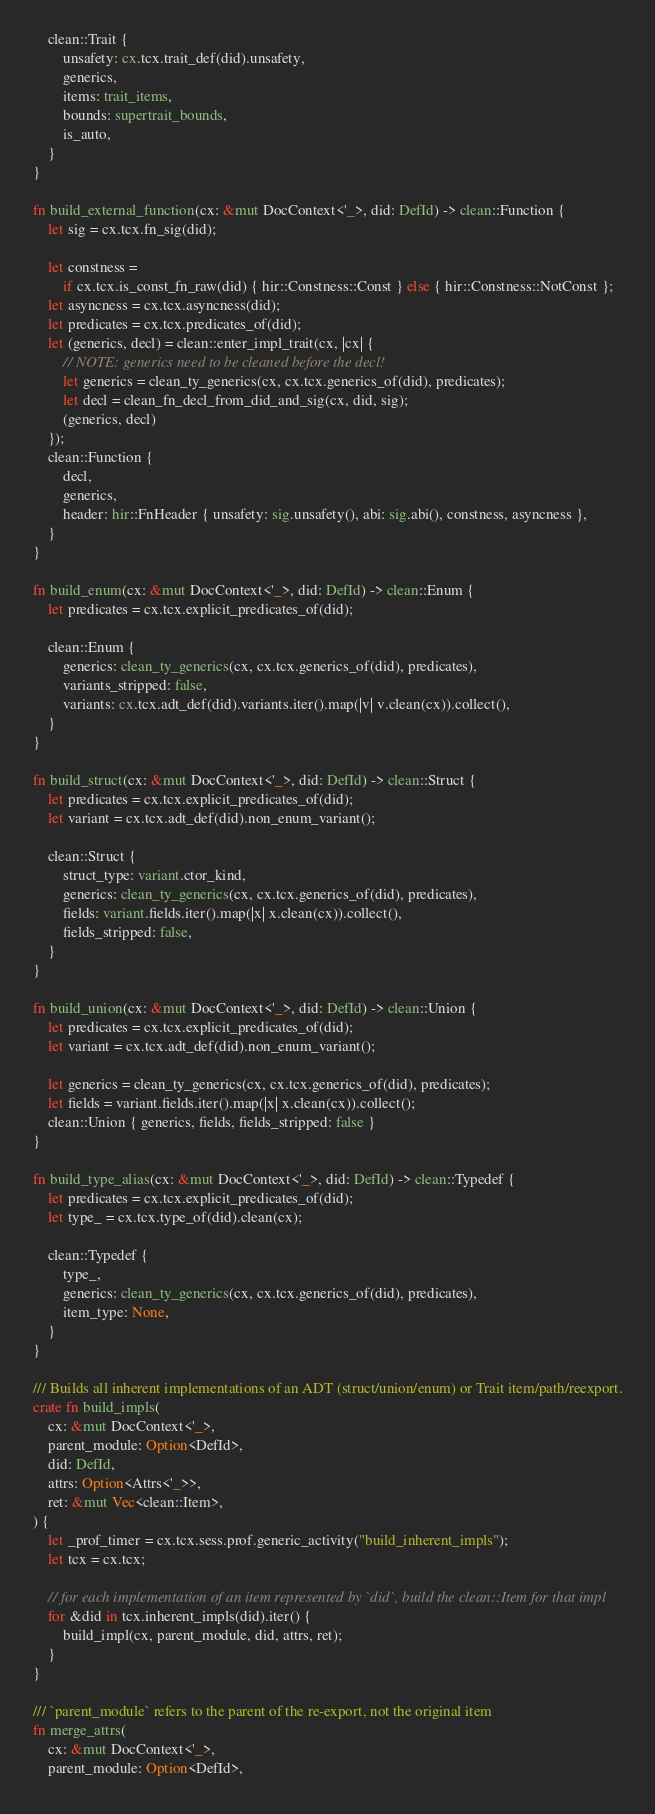Convert code to text. <code><loc_0><loc_0><loc_500><loc_500><_Rust_>    clean::Trait {
        unsafety: cx.tcx.trait_def(did).unsafety,
        generics,
        items: trait_items,
        bounds: supertrait_bounds,
        is_auto,
    }
}

fn build_external_function(cx: &mut DocContext<'_>, did: DefId) -> clean::Function {
    let sig = cx.tcx.fn_sig(did);

    let constness =
        if cx.tcx.is_const_fn_raw(did) { hir::Constness::Const } else { hir::Constness::NotConst };
    let asyncness = cx.tcx.asyncness(did);
    let predicates = cx.tcx.predicates_of(did);
    let (generics, decl) = clean::enter_impl_trait(cx, |cx| {
        // NOTE: generics need to be cleaned before the decl!
        let generics = clean_ty_generics(cx, cx.tcx.generics_of(did), predicates);
        let decl = clean_fn_decl_from_did_and_sig(cx, did, sig);
        (generics, decl)
    });
    clean::Function {
        decl,
        generics,
        header: hir::FnHeader { unsafety: sig.unsafety(), abi: sig.abi(), constness, asyncness },
    }
}

fn build_enum(cx: &mut DocContext<'_>, did: DefId) -> clean::Enum {
    let predicates = cx.tcx.explicit_predicates_of(did);

    clean::Enum {
        generics: clean_ty_generics(cx, cx.tcx.generics_of(did), predicates),
        variants_stripped: false,
        variants: cx.tcx.adt_def(did).variants.iter().map(|v| v.clean(cx)).collect(),
    }
}

fn build_struct(cx: &mut DocContext<'_>, did: DefId) -> clean::Struct {
    let predicates = cx.tcx.explicit_predicates_of(did);
    let variant = cx.tcx.adt_def(did).non_enum_variant();

    clean::Struct {
        struct_type: variant.ctor_kind,
        generics: clean_ty_generics(cx, cx.tcx.generics_of(did), predicates),
        fields: variant.fields.iter().map(|x| x.clean(cx)).collect(),
        fields_stripped: false,
    }
}

fn build_union(cx: &mut DocContext<'_>, did: DefId) -> clean::Union {
    let predicates = cx.tcx.explicit_predicates_of(did);
    let variant = cx.tcx.adt_def(did).non_enum_variant();

    let generics = clean_ty_generics(cx, cx.tcx.generics_of(did), predicates);
    let fields = variant.fields.iter().map(|x| x.clean(cx)).collect();
    clean::Union { generics, fields, fields_stripped: false }
}

fn build_type_alias(cx: &mut DocContext<'_>, did: DefId) -> clean::Typedef {
    let predicates = cx.tcx.explicit_predicates_of(did);
    let type_ = cx.tcx.type_of(did).clean(cx);

    clean::Typedef {
        type_,
        generics: clean_ty_generics(cx, cx.tcx.generics_of(did), predicates),
        item_type: None,
    }
}

/// Builds all inherent implementations of an ADT (struct/union/enum) or Trait item/path/reexport.
crate fn build_impls(
    cx: &mut DocContext<'_>,
    parent_module: Option<DefId>,
    did: DefId,
    attrs: Option<Attrs<'_>>,
    ret: &mut Vec<clean::Item>,
) {
    let _prof_timer = cx.tcx.sess.prof.generic_activity("build_inherent_impls");
    let tcx = cx.tcx;

    // for each implementation of an item represented by `did`, build the clean::Item for that impl
    for &did in tcx.inherent_impls(did).iter() {
        build_impl(cx, parent_module, did, attrs, ret);
    }
}

/// `parent_module` refers to the parent of the re-export, not the original item
fn merge_attrs(
    cx: &mut DocContext<'_>,
    parent_module: Option<DefId>,</code> 